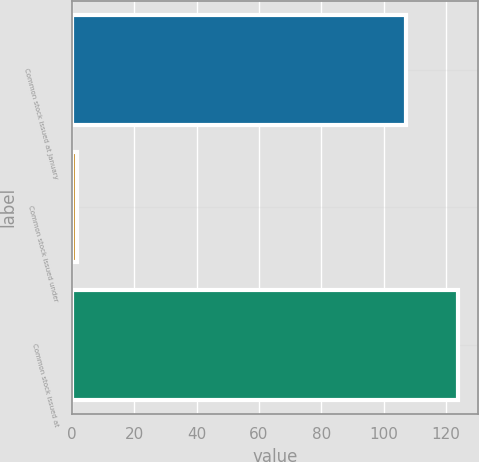Convert chart. <chart><loc_0><loc_0><loc_500><loc_500><bar_chart><fcel>Common stock issued at January<fcel>Common stock issued under<fcel>Common stock issued at<nl><fcel>107.1<fcel>1.5<fcel>123.9<nl></chart> 